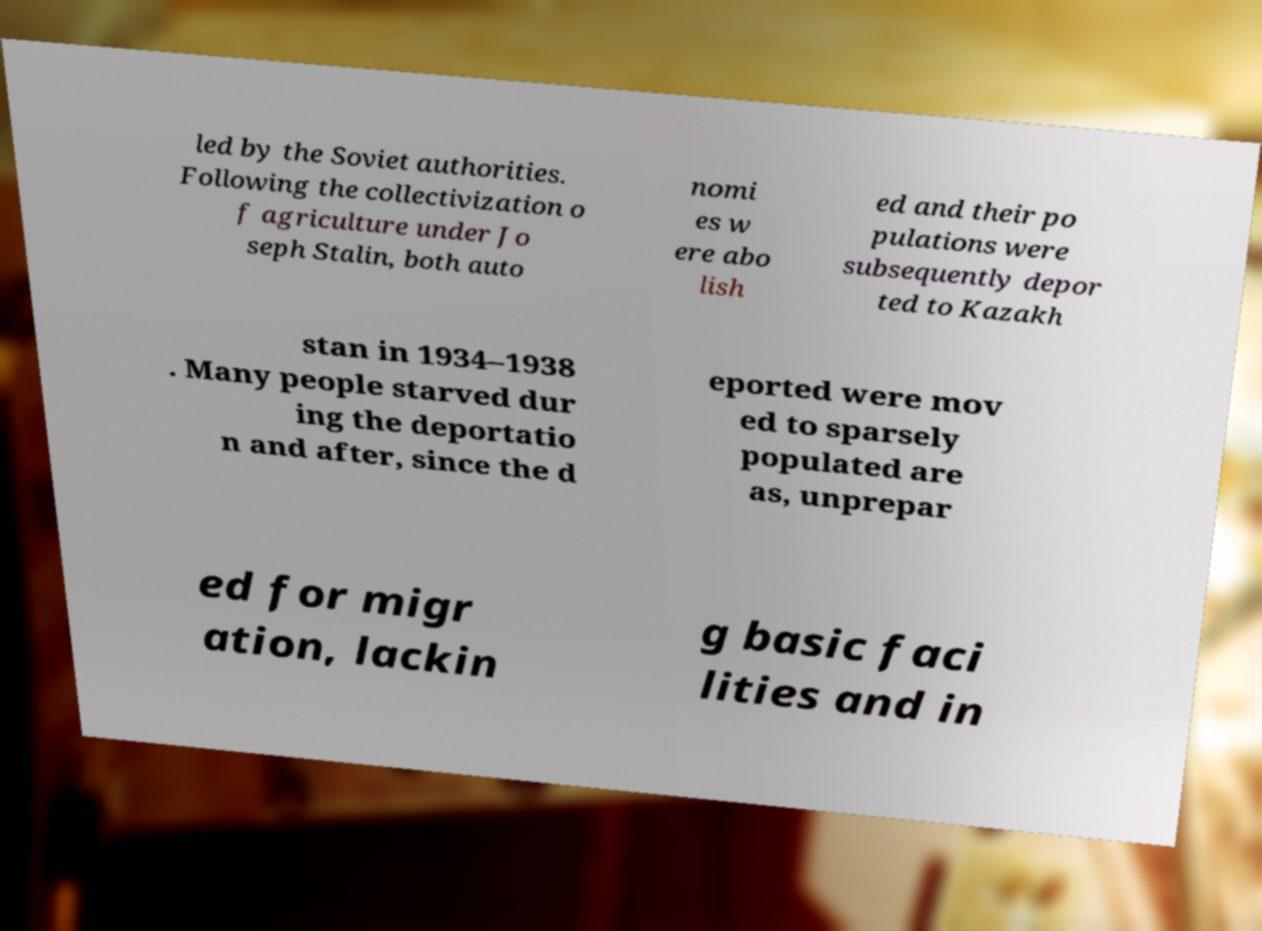Please identify and transcribe the text found in this image. led by the Soviet authorities. Following the collectivization o f agriculture under Jo seph Stalin, both auto nomi es w ere abo lish ed and their po pulations were subsequently depor ted to Kazakh stan in 1934–1938 . Many people starved dur ing the deportatio n and after, since the d eported were mov ed to sparsely populated are as, unprepar ed for migr ation, lackin g basic faci lities and in 